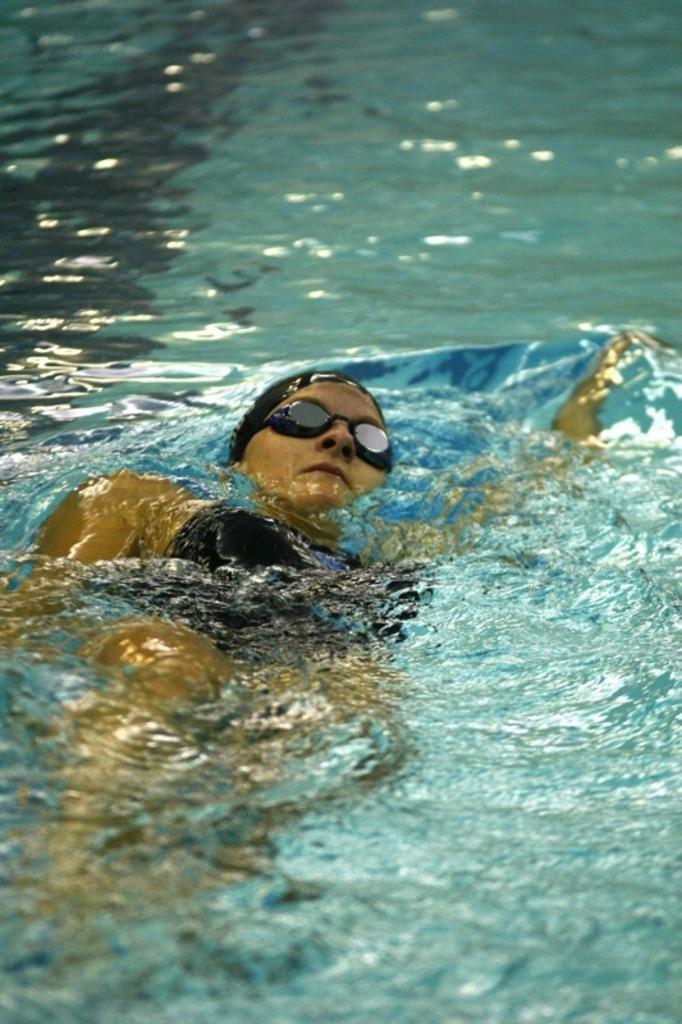Please provide a concise description of this image. This image consists of a woman swimming. She is wearing black dress and black glasses. At the bottom, we can see the water. 